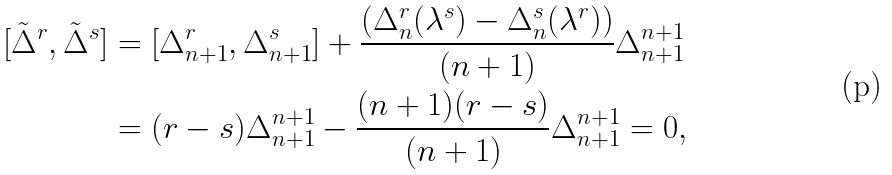Convert formula to latex. <formula><loc_0><loc_0><loc_500><loc_500>[ \tilde { \Delta } ^ { r } , \tilde { \Delta } ^ { s } ] & = [ \Delta ^ { r } _ { n + 1 } , \Delta ^ { s } _ { n + 1 } ] + \frac { ( \Delta ^ { r } _ { n } ( \lambda ^ { s } ) - \Delta ^ { s } _ { n } ( \lambda ^ { r } ) ) } { ( n + 1 ) } \Delta ^ { n + 1 } _ { n + 1 } \\ & = ( r - s ) \Delta ^ { n + 1 } _ { n + 1 } - \frac { ( n + 1 ) ( r - s ) } { ( n + 1 ) } \Delta ^ { n + 1 } _ { n + 1 } = 0 ,</formula> 